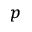Convert formula to latex. <formula><loc_0><loc_0><loc_500><loc_500>_ { p }</formula> 